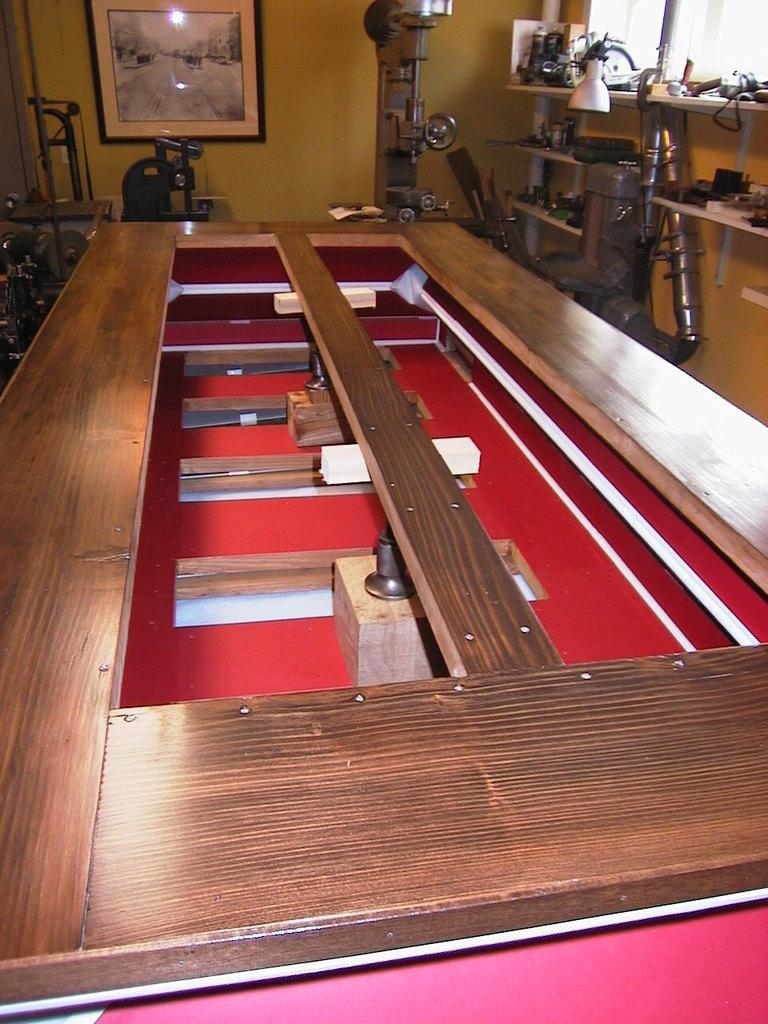What type of furniture is present in the image? There is a table in the image. What else can be seen in the image besides the table? There are machines and a wall painting visible in the image. Are there any storage units in the image? Yes, there is a shelf in the image. Can you describe the setting where the image was taken? The image may have been taken in a hall. What type of paper is being used to wrap the pickle in the image? There is no pickle or paper present in the image. 